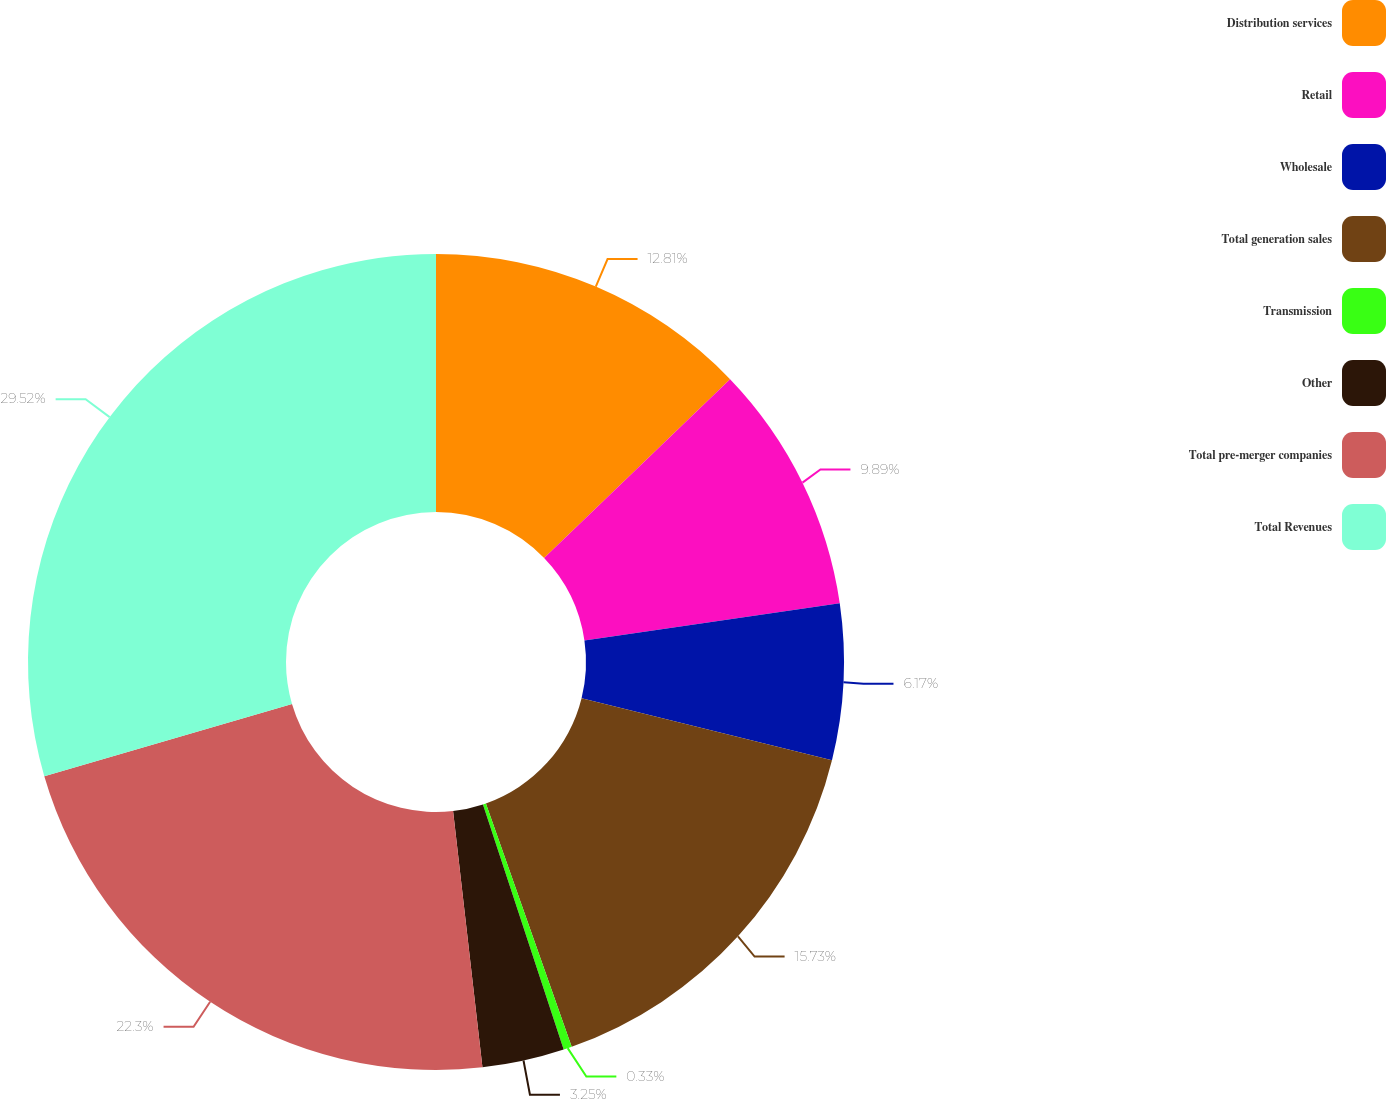<chart> <loc_0><loc_0><loc_500><loc_500><pie_chart><fcel>Distribution services<fcel>Retail<fcel>Wholesale<fcel>Total generation sales<fcel>Transmission<fcel>Other<fcel>Total pre-merger companies<fcel>Total Revenues<nl><fcel>12.81%<fcel>9.89%<fcel>6.17%<fcel>15.73%<fcel>0.33%<fcel>3.25%<fcel>22.3%<fcel>29.51%<nl></chart> 